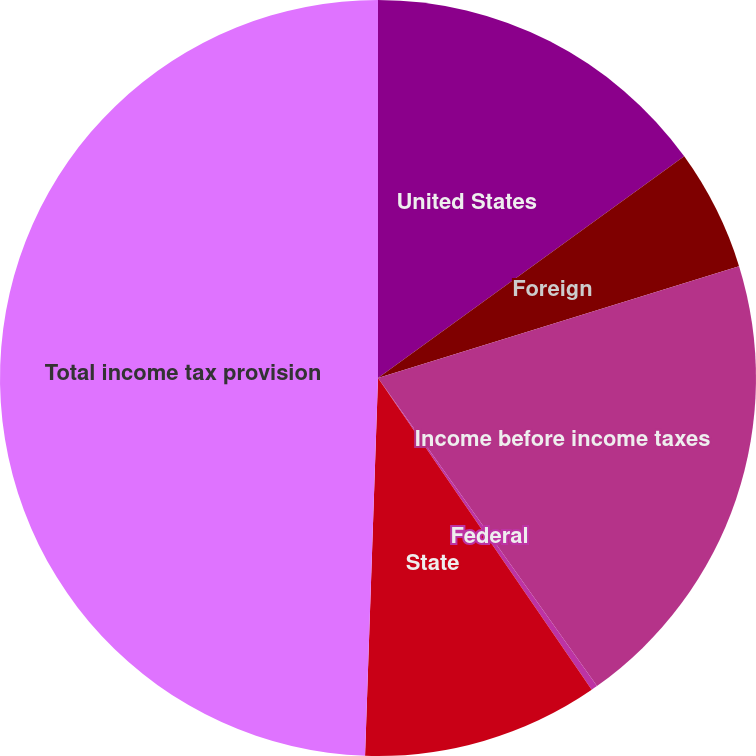<chart> <loc_0><loc_0><loc_500><loc_500><pie_chart><fcel>United States<fcel>Foreign<fcel>Income before income taxes<fcel>Federal<fcel>State<fcel>Total income tax provision<nl><fcel>15.03%<fcel>5.19%<fcel>19.95%<fcel>0.27%<fcel>10.11%<fcel>49.46%<nl></chart> 